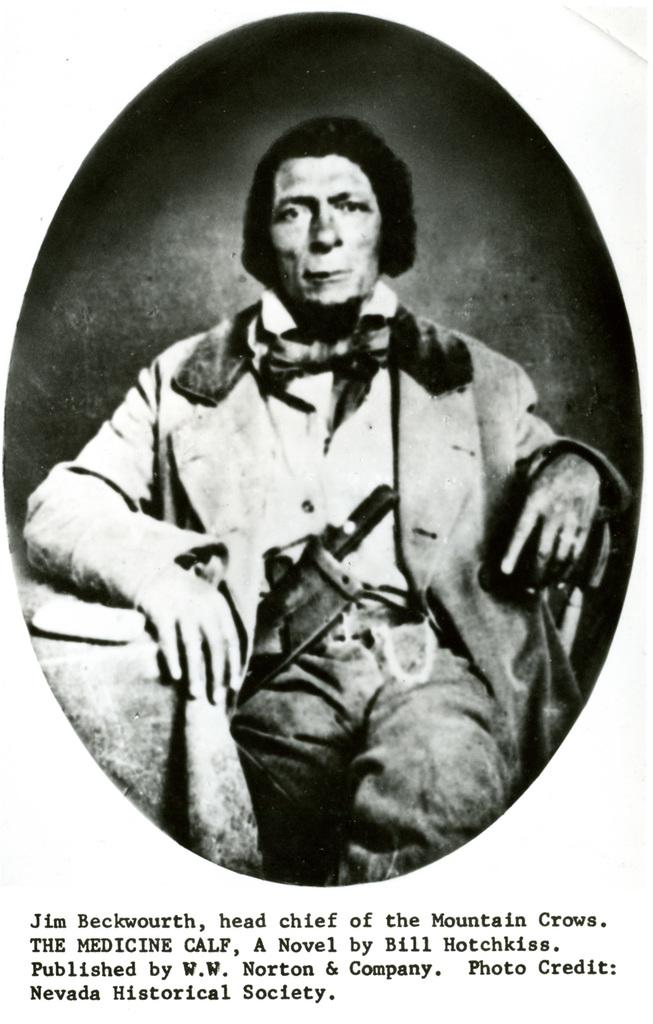What is the color scheme of the image? The image is black and white. Who is present in the image? There is a man in the image. What is the man wearing? The man is wearing a coat. What is the man doing in the image? The man is sitting. What can be found at the bottom of the image? There is text at the bottom of the image. How many babies are visible in the image? There are no babies present in the image. What type of pies is the grandmother making in the image? There is no grandmother or pies present in the image. 